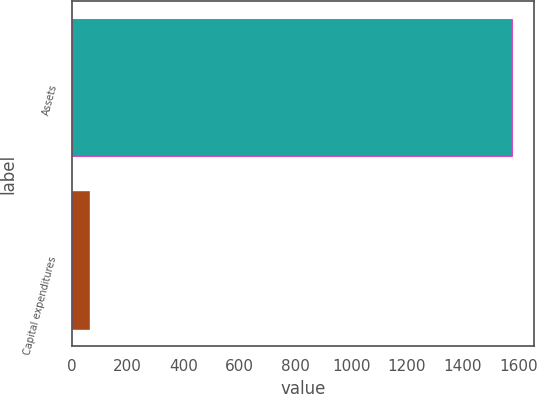<chart> <loc_0><loc_0><loc_500><loc_500><bar_chart><fcel>Assets<fcel>Capital expenditures<nl><fcel>1577<fcel>62<nl></chart> 